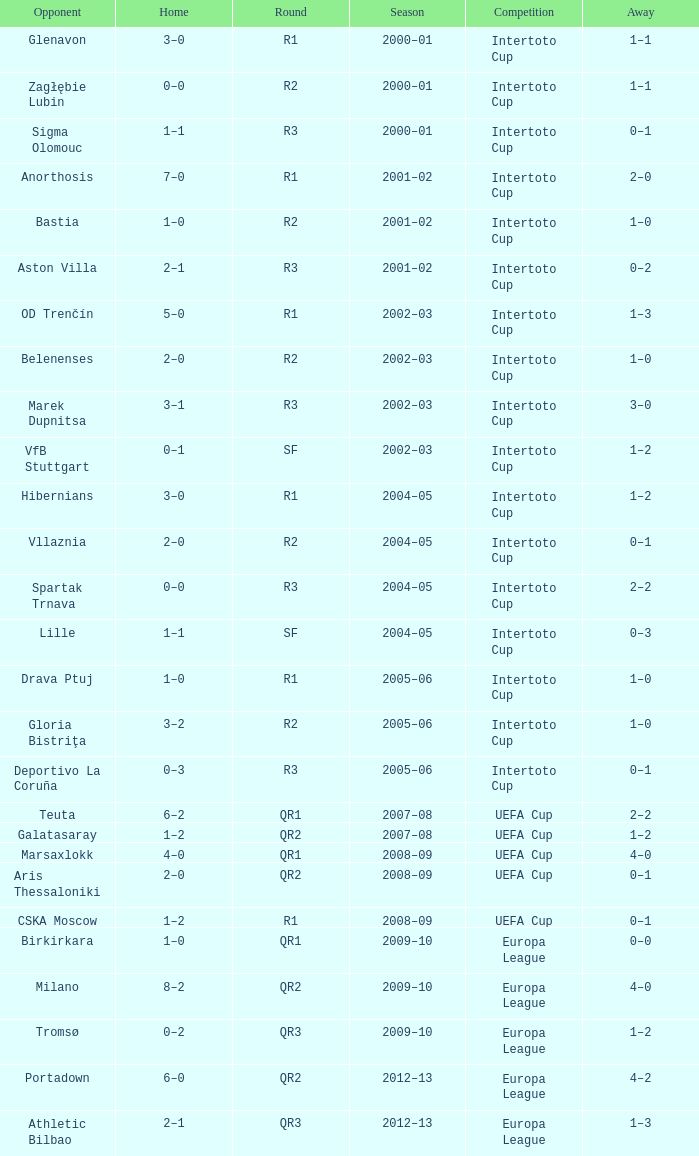What is the home score with marek dupnitsa as opponent? 3–1. 